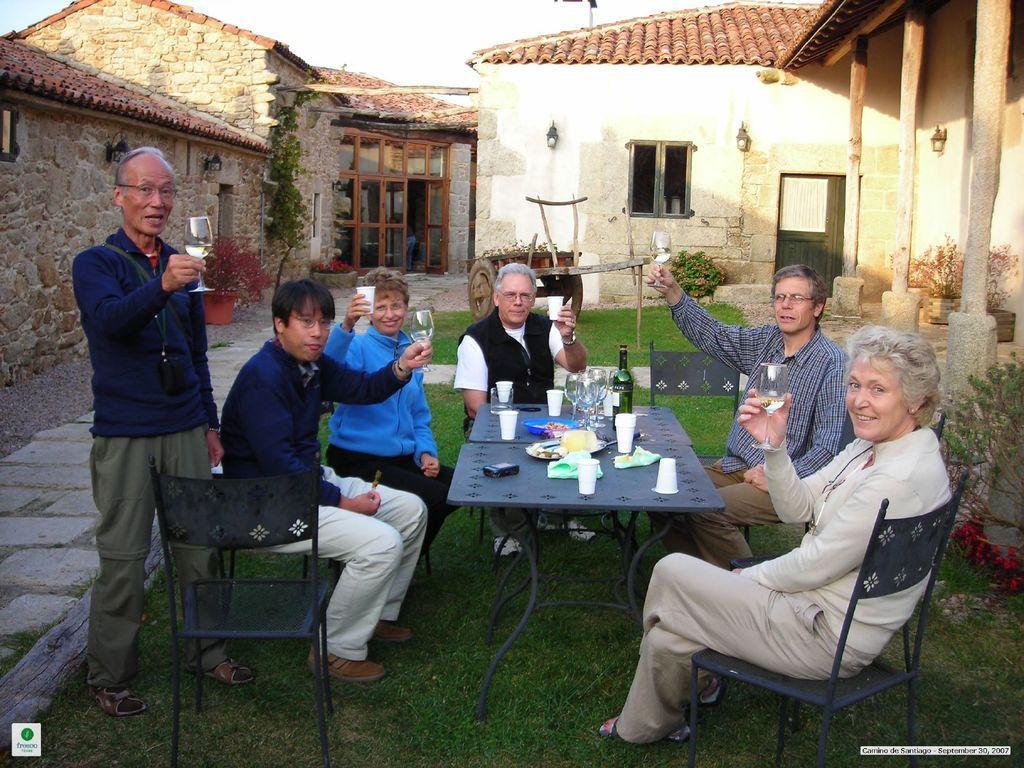Can you describe this image briefly? In this picture we can see some persons are sitting on the chairs in front of them there is a table on the table we have a glasses cups in the persons are holding glasses filled with liquid back side we can see houses Windows doors Down we can see a Grass. 